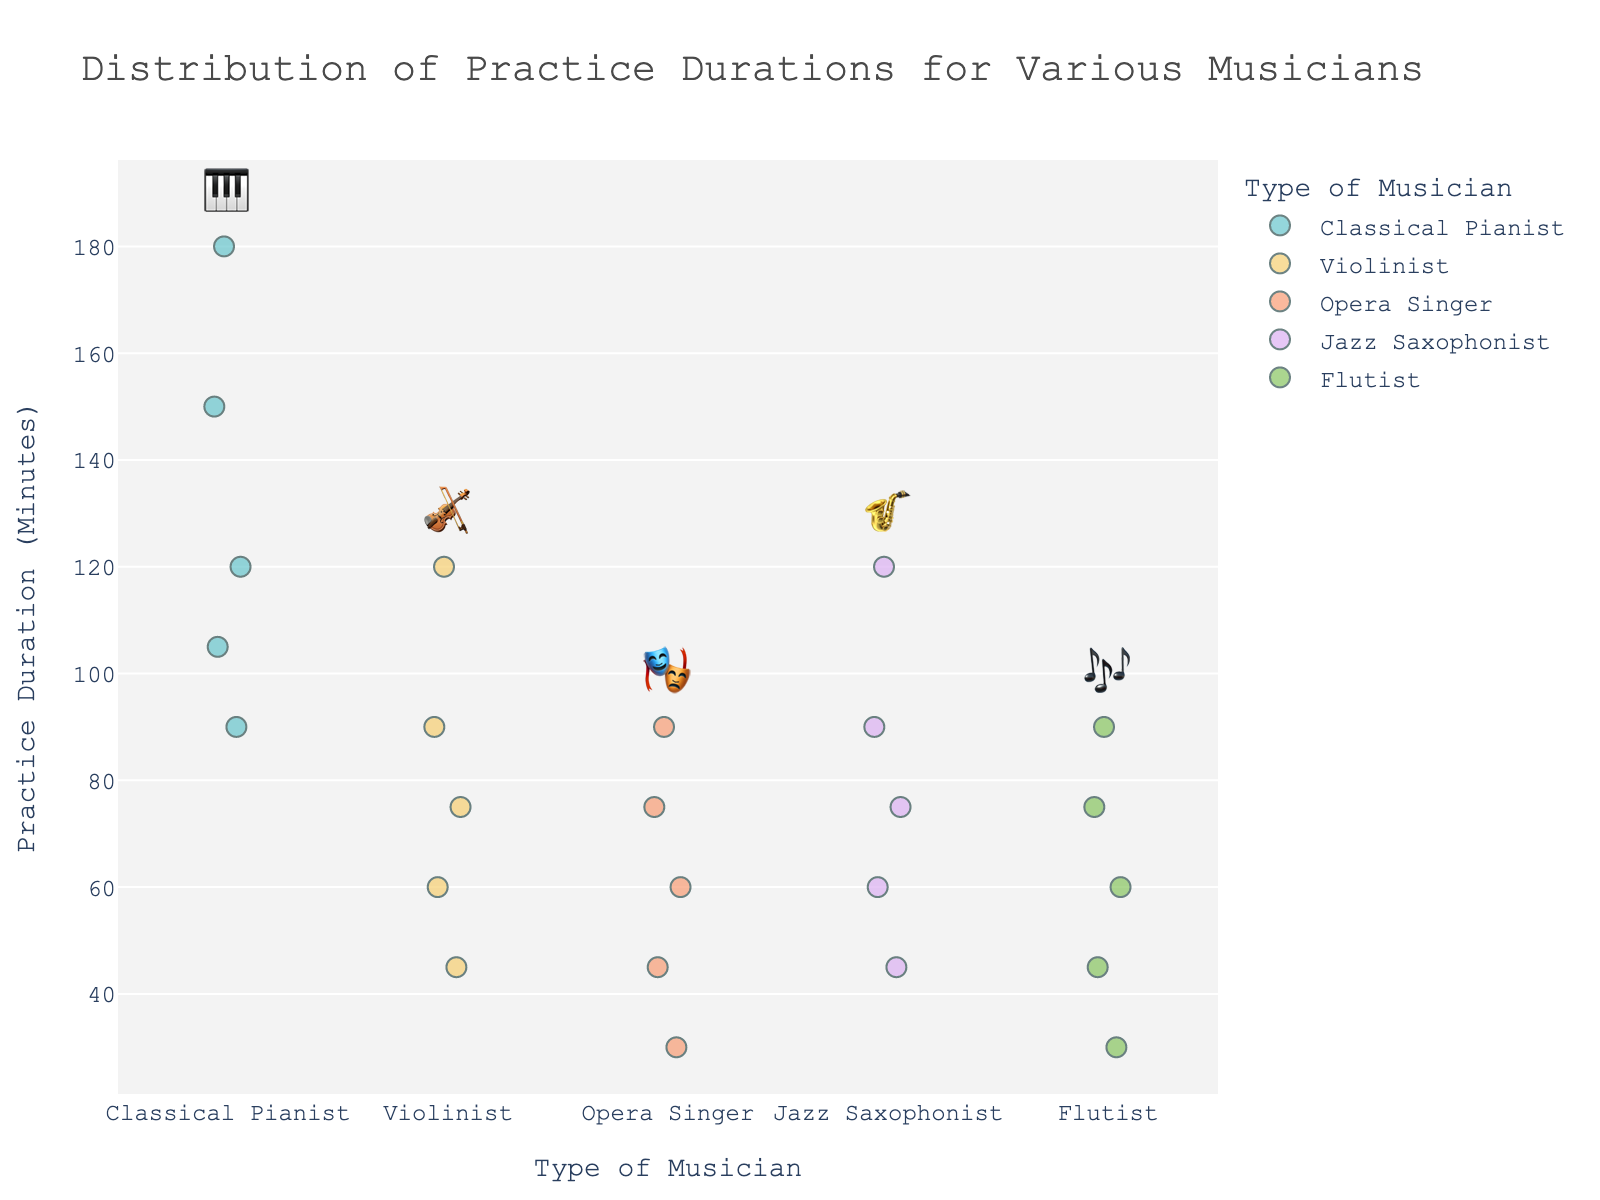what is the title of the plot? The title is typically displayed at the top of the figure and visually distinguishes the subject matter of the chart.
Answer: Distribution of Practice Durations for Various Musicians How many different types of musicians are represented? Different musician types are categorized along the x-axis, each represented by distinct icons.
Answer: 5 Which type of musician has the longest practice duration? To determine this, observe the highest point on the y-axis for each musician type. The Classical Pianist has the highest value at 180 minutes.
Answer: Classical Pianist What is the range of practice durations for Violinists? The range can be found by locating the highest and lowest points on the y-axis for Violinists, which are 120 minutes and 45 minutes respectively. The range is calculated as 120 - 45 = 75 minutes.
Answer: 75 minutes Which musician type appears to have the most varied practice durations? By visually inspecting the spread of points along the y-axis, the Flutist displays a wide distribution from 30 to 90 minutes.
Answer: Flutist How does the median practice duration of Jazz Saxophonists compare to that of Opera Singers? Find the central value for each category's data points. For Jazz Saxophonists: [45, 60, 75, 90, 120] with median = 75. For Opera Singers: [30, 45, 60, 75, 90] with median = 60.
Answer: Jazz Saxophonists have a higher median Which two musician types have the closest maximum practice durations? Identify the highest values of each type: Classical Pianist (180), Violinist (120), Opera Singer (90), Jazz Saxophonist (120), Flutist (90). The Violinist and Jazz Saxophonist both max out at 120 minutes.
Answer: Violinist and Jazz Saxophonist Are there any ties in practice durations among different musician types? Scan for identical y-axis values across categories. Both an Opera Singer and Violinist practiced for 90 minutes.
Answer: Yes, at 90 minutes 